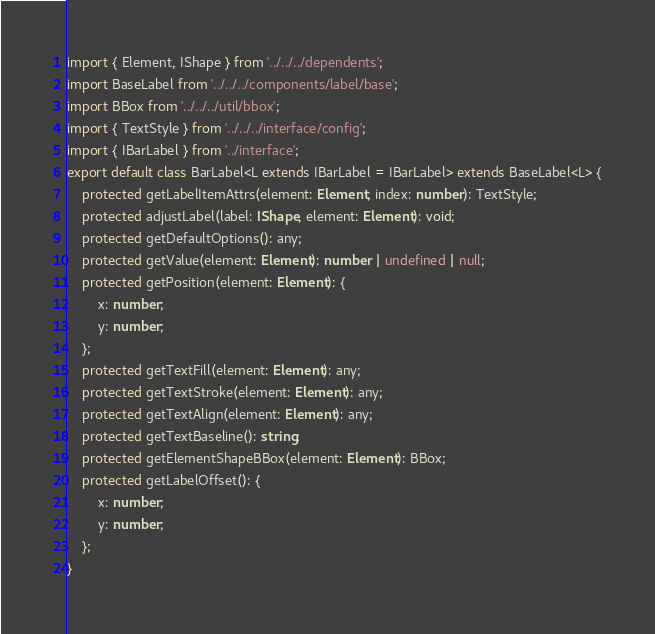Convert code to text. <code><loc_0><loc_0><loc_500><loc_500><_TypeScript_>import { Element, IShape } from '../../../dependents';
import BaseLabel from '../../../components/label/base';
import BBox from '../../../util/bbox';
import { TextStyle } from '../../../interface/config';
import { IBarLabel } from '../interface';
export default class BarLabel<L extends IBarLabel = IBarLabel> extends BaseLabel<L> {
    protected getLabelItemAttrs(element: Element, index: number): TextStyle;
    protected adjustLabel(label: IShape, element: Element): void;
    protected getDefaultOptions(): any;
    protected getValue(element: Element): number | undefined | null;
    protected getPosition(element: Element): {
        x: number;
        y: number;
    };
    protected getTextFill(element: Element): any;
    protected getTextStroke(element: Element): any;
    protected getTextAlign(element: Element): any;
    protected getTextBaseline(): string;
    protected getElementShapeBBox(element: Element): BBox;
    protected getLabelOffset(): {
        x: number;
        y: number;
    };
}
</code> 